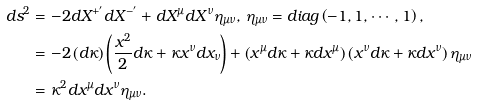Convert formula to latex. <formula><loc_0><loc_0><loc_500><loc_500>d s ^ { 2 } & = - 2 d X ^ { + ^ { \prime } } d X ^ { - ^ { \prime } } + d X ^ { \mu } d X ^ { \nu } \eta _ { \mu \nu } , \, \eta _ { \mu \nu } = d i a g \left ( - 1 , 1 , \cdots , 1 \right ) , \\ & = - 2 \left ( d \kappa \right ) \left ( \frac { x ^ { 2 } } { 2 } d \kappa + \kappa x ^ { \nu } d x _ { \nu } \right ) + \left ( x ^ { \mu } d \kappa + \kappa d x ^ { \mu } \right ) \left ( x ^ { \nu } d \kappa + \kappa d x ^ { \nu } \right ) \eta _ { \mu \nu } \\ & = \kappa ^ { 2 } d x ^ { \mu } d x ^ { \nu } \eta _ { \mu \nu } .</formula> 